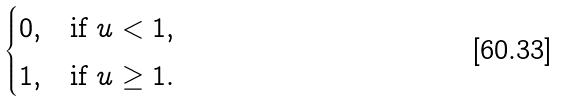Convert formula to latex. <formula><loc_0><loc_0><loc_500><loc_500>\begin{cases} 0 , & \text {if} \ u < 1 , \\ 1 , & \text {if} \ u \geq 1 . \end{cases}</formula> 